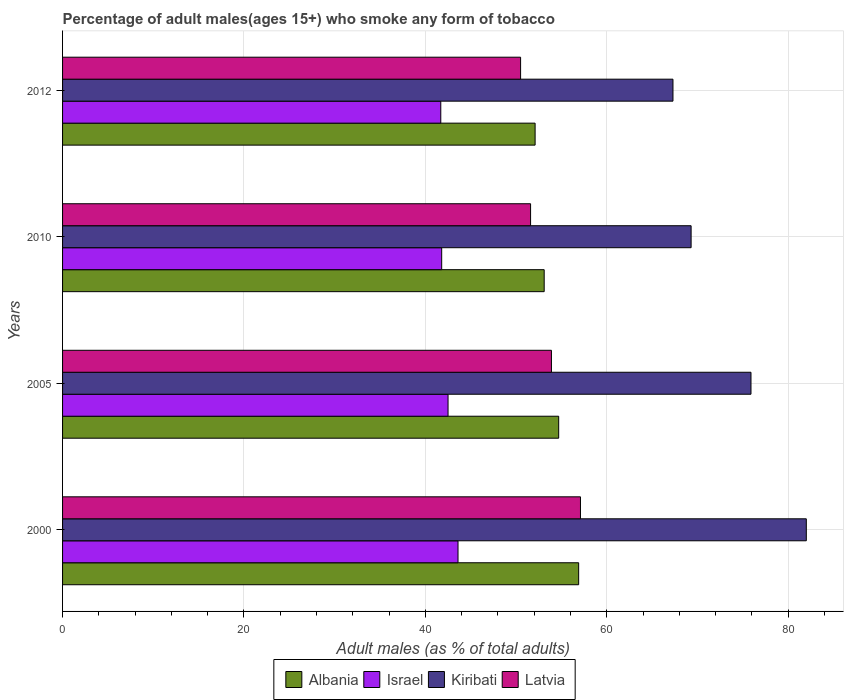How many groups of bars are there?
Your answer should be compact. 4. Are the number of bars per tick equal to the number of legend labels?
Provide a short and direct response. Yes. How many bars are there on the 4th tick from the bottom?
Your answer should be compact. 4. In how many cases, is the number of bars for a given year not equal to the number of legend labels?
Ensure brevity in your answer.  0. What is the percentage of adult males who smoke in Kiribati in 2012?
Offer a very short reply. 67.3. Across all years, what is the maximum percentage of adult males who smoke in Kiribati?
Keep it short and to the point. 82. Across all years, what is the minimum percentage of adult males who smoke in Israel?
Give a very brief answer. 41.7. In which year was the percentage of adult males who smoke in Latvia maximum?
Offer a very short reply. 2000. In which year was the percentage of adult males who smoke in Israel minimum?
Offer a terse response. 2012. What is the total percentage of adult males who smoke in Israel in the graph?
Your response must be concise. 169.6. What is the difference between the percentage of adult males who smoke in Israel in 2005 and that in 2012?
Offer a very short reply. 0.8. What is the difference between the percentage of adult males who smoke in Latvia in 2005 and the percentage of adult males who smoke in Albania in 2012?
Your response must be concise. 1.8. What is the average percentage of adult males who smoke in Albania per year?
Ensure brevity in your answer.  54.2. In the year 2010, what is the difference between the percentage of adult males who smoke in Albania and percentage of adult males who smoke in Kiribati?
Give a very brief answer. -16.2. In how many years, is the percentage of adult males who smoke in Latvia greater than 48 %?
Your answer should be compact. 4. What is the ratio of the percentage of adult males who smoke in Albania in 2005 to that in 2012?
Provide a succinct answer. 1.05. Is the percentage of adult males who smoke in Kiribati in 2000 less than that in 2005?
Provide a succinct answer. No. What is the difference between the highest and the second highest percentage of adult males who smoke in Albania?
Provide a short and direct response. 2.2. What is the difference between the highest and the lowest percentage of adult males who smoke in Israel?
Make the answer very short. 1.9. In how many years, is the percentage of adult males who smoke in Kiribati greater than the average percentage of adult males who smoke in Kiribati taken over all years?
Ensure brevity in your answer.  2. Is the sum of the percentage of adult males who smoke in Latvia in 2000 and 2005 greater than the maximum percentage of adult males who smoke in Kiribati across all years?
Give a very brief answer. Yes. Is it the case that in every year, the sum of the percentage of adult males who smoke in Latvia and percentage of adult males who smoke in Albania is greater than the sum of percentage of adult males who smoke in Kiribati and percentage of adult males who smoke in Israel?
Your answer should be compact. No. What does the 4th bar from the top in 2012 represents?
Provide a short and direct response. Albania. What does the 1st bar from the bottom in 2000 represents?
Make the answer very short. Albania. Are all the bars in the graph horizontal?
Make the answer very short. Yes. How many years are there in the graph?
Offer a very short reply. 4. Are the values on the major ticks of X-axis written in scientific E-notation?
Give a very brief answer. No. Does the graph contain any zero values?
Offer a very short reply. No. Where does the legend appear in the graph?
Keep it short and to the point. Bottom center. How are the legend labels stacked?
Your answer should be compact. Horizontal. What is the title of the graph?
Provide a short and direct response. Percentage of adult males(ages 15+) who smoke any form of tobacco. What is the label or title of the X-axis?
Offer a very short reply. Adult males (as % of total adults). What is the Adult males (as % of total adults) of Albania in 2000?
Your answer should be very brief. 56.9. What is the Adult males (as % of total adults) of Israel in 2000?
Your answer should be compact. 43.6. What is the Adult males (as % of total adults) in Latvia in 2000?
Offer a very short reply. 57.1. What is the Adult males (as % of total adults) in Albania in 2005?
Offer a terse response. 54.7. What is the Adult males (as % of total adults) of Israel in 2005?
Give a very brief answer. 42.5. What is the Adult males (as % of total adults) in Kiribati in 2005?
Offer a very short reply. 75.9. What is the Adult males (as % of total adults) in Latvia in 2005?
Keep it short and to the point. 53.9. What is the Adult males (as % of total adults) of Albania in 2010?
Provide a short and direct response. 53.1. What is the Adult males (as % of total adults) in Israel in 2010?
Give a very brief answer. 41.8. What is the Adult males (as % of total adults) of Kiribati in 2010?
Provide a succinct answer. 69.3. What is the Adult males (as % of total adults) of Latvia in 2010?
Your answer should be very brief. 51.6. What is the Adult males (as % of total adults) of Albania in 2012?
Make the answer very short. 52.1. What is the Adult males (as % of total adults) in Israel in 2012?
Offer a terse response. 41.7. What is the Adult males (as % of total adults) in Kiribati in 2012?
Your response must be concise. 67.3. What is the Adult males (as % of total adults) of Latvia in 2012?
Keep it short and to the point. 50.5. Across all years, what is the maximum Adult males (as % of total adults) in Albania?
Ensure brevity in your answer.  56.9. Across all years, what is the maximum Adult males (as % of total adults) of Israel?
Offer a very short reply. 43.6. Across all years, what is the maximum Adult males (as % of total adults) in Latvia?
Ensure brevity in your answer.  57.1. Across all years, what is the minimum Adult males (as % of total adults) of Albania?
Your answer should be compact. 52.1. Across all years, what is the minimum Adult males (as % of total adults) of Israel?
Offer a very short reply. 41.7. Across all years, what is the minimum Adult males (as % of total adults) of Kiribati?
Provide a succinct answer. 67.3. Across all years, what is the minimum Adult males (as % of total adults) of Latvia?
Provide a short and direct response. 50.5. What is the total Adult males (as % of total adults) in Albania in the graph?
Offer a very short reply. 216.8. What is the total Adult males (as % of total adults) of Israel in the graph?
Give a very brief answer. 169.6. What is the total Adult males (as % of total adults) in Kiribati in the graph?
Offer a terse response. 294.5. What is the total Adult males (as % of total adults) in Latvia in the graph?
Your answer should be very brief. 213.1. What is the difference between the Adult males (as % of total adults) of Israel in 2000 and that in 2005?
Offer a very short reply. 1.1. What is the difference between the Adult males (as % of total adults) in Albania in 2000 and that in 2010?
Keep it short and to the point. 3.8. What is the difference between the Adult males (as % of total adults) in Israel in 2000 and that in 2010?
Keep it short and to the point. 1.8. What is the difference between the Adult males (as % of total adults) in Latvia in 2000 and that in 2010?
Provide a short and direct response. 5.5. What is the difference between the Adult males (as % of total adults) in Albania in 2000 and that in 2012?
Your response must be concise. 4.8. What is the difference between the Adult males (as % of total adults) in Kiribati in 2000 and that in 2012?
Make the answer very short. 14.7. What is the difference between the Adult males (as % of total adults) in Israel in 2005 and that in 2012?
Give a very brief answer. 0.8. What is the difference between the Adult males (as % of total adults) in Latvia in 2005 and that in 2012?
Give a very brief answer. 3.4. What is the difference between the Adult males (as % of total adults) in Kiribati in 2010 and that in 2012?
Your answer should be very brief. 2. What is the difference between the Adult males (as % of total adults) of Latvia in 2010 and that in 2012?
Your answer should be compact. 1.1. What is the difference between the Adult males (as % of total adults) in Albania in 2000 and the Adult males (as % of total adults) in Israel in 2005?
Offer a terse response. 14.4. What is the difference between the Adult males (as % of total adults) of Albania in 2000 and the Adult males (as % of total adults) of Latvia in 2005?
Offer a terse response. 3. What is the difference between the Adult males (as % of total adults) of Israel in 2000 and the Adult males (as % of total adults) of Kiribati in 2005?
Provide a succinct answer. -32.3. What is the difference between the Adult males (as % of total adults) of Kiribati in 2000 and the Adult males (as % of total adults) of Latvia in 2005?
Keep it short and to the point. 28.1. What is the difference between the Adult males (as % of total adults) of Albania in 2000 and the Adult males (as % of total adults) of Israel in 2010?
Offer a very short reply. 15.1. What is the difference between the Adult males (as % of total adults) in Albania in 2000 and the Adult males (as % of total adults) in Kiribati in 2010?
Provide a short and direct response. -12.4. What is the difference between the Adult males (as % of total adults) of Albania in 2000 and the Adult males (as % of total adults) of Latvia in 2010?
Give a very brief answer. 5.3. What is the difference between the Adult males (as % of total adults) in Israel in 2000 and the Adult males (as % of total adults) in Kiribati in 2010?
Make the answer very short. -25.7. What is the difference between the Adult males (as % of total adults) of Israel in 2000 and the Adult males (as % of total adults) of Latvia in 2010?
Your answer should be very brief. -8. What is the difference between the Adult males (as % of total adults) of Kiribati in 2000 and the Adult males (as % of total adults) of Latvia in 2010?
Offer a terse response. 30.4. What is the difference between the Adult males (as % of total adults) of Israel in 2000 and the Adult males (as % of total adults) of Kiribati in 2012?
Provide a short and direct response. -23.7. What is the difference between the Adult males (as % of total adults) in Israel in 2000 and the Adult males (as % of total adults) in Latvia in 2012?
Your answer should be very brief. -6.9. What is the difference between the Adult males (as % of total adults) in Kiribati in 2000 and the Adult males (as % of total adults) in Latvia in 2012?
Provide a short and direct response. 31.5. What is the difference between the Adult males (as % of total adults) of Albania in 2005 and the Adult males (as % of total adults) of Israel in 2010?
Offer a terse response. 12.9. What is the difference between the Adult males (as % of total adults) of Albania in 2005 and the Adult males (as % of total adults) of Kiribati in 2010?
Your answer should be compact. -14.6. What is the difference between the Adult males (as % of total adults) of Israel in 2005 and the Adult males (as % of total adults) of Kiribati in 2010?
Your answer should be very brief. -26.8. What is the difference between the Adult males (as % of total adults) in Kiribati in 2005 and the Adult males (as % of total adults) in Latvia in 2010?
Give a very brief answer. 24.3. What is the difference between the Adult males (as % of total adults) of Albania in 2005 and the Adult males (as % of total adults) of Kiribati in 2012?
Your answer should be compact. -12.6. What is the difference between the Adult males (as % of total adults) of Israel in 2005 and the Adult males (as % of total adults) of Kiribati in 2012?
Keep it short and to the point. -24.8. What is the difference between the Adult males (as % of total adults) in Israel in 2005 and the Adult males (as % of total adults) in Latvia in 2012?
Provide a short and direct response. -8. What is the difference between the Adult males (as % of total adults) in Kiribati in 2005 and the Adult males (as % of total adults) in Latvia in 2012?
Provide a short and direct response. 25.4. What is the difference between the Adult males (as % of total adults) of Israel in 2010 and the Adult males (as % of total adults) of Kiribati in 2012?
Make the answer very short. -25.5. What is the difference between the Adult males (as % of total adults) in Israel in 2010 and the Adult males (as % of total adults) in Latvia in 2012?
Offer a terse response. -8.7. What is the difference between the Adult males (as % of total adults) of Kiribati in 2010 and the Adult males (as % of total adults) of Latvia in 2012?
Provide a succinct answer. 18.8. What is the average Adult males (as % of total adults) in Albania per year?
Your answer should be compact. 54.2. What is the average Adult males (as % of total adults) in Israel per year?
Your answer should be very brief. 42.4. What is the average Adult males (as % of total adults) of Kiribati per year?
Your answer should be very brief. 73.62. What is the average Adult males (as % of total adults) of Latvia per year?
Offer a very short reply. 53.27. In the year 2000, what is the difference between the Adult males (as % of total adults) in Albania and Adult males (as % of total adults) in Kiribati?
Your response must be concise. -25.1. In the year 2000, what is the difference between the Adult males (as % of total adults) of Israel and Adult males (as % of total adults) of Kiribati?
Provide a succinct answer. -38.4. In the year 2000, what is the difference between the Adult males (as % of total adults) in Israel and Adult males (as % of total adults) in Latvia?
Offer a terse response. -13.5. In the year 2000, what is the difference between the Adult males (as % of total adults) of Kiribati and Adult males (as % of total adults) of Latvia?
Offer a very short reply. 24.9. In the year 2005, what is the difference between the Adult males (as % of total adults) in Albania and Adult males (as % of total adults) in Israel?
Your response must be concise. 12.2. In the year 2005, what is the difference between the Adult males (as % of total adults) of Albania and Adult males (as % of total adults) of Kiribati?
Your response must be concise. -21.2. In the year 2005, what is the difference between the Adult males (as % of total adults) in Israel and Adult males (as % of total adults) in Kiribati?
Your answer should be very brief. -33.4. In the year 2010, what is the difference between the Adult males (as % of total adults) in Albania and Adult males (as % of total adults) in Israel?
Provide a succinct answer. 11.3. In the year 2010, what is the difference between the Adult males (as % of total adults) in Albania and Adult males (as % of total adults) in Kiribati?
Provide a succinct answer. -16.2. In the year 2010, what is the difference between the Adult males (as % of total adults) of Albania and Adult males (as % of total adults) of Latvia?
Offer a terse response. 1.5. In the year 2010, what is the difference between the Adult males (as % of total adults) in Israel and Adult males (as % of total adults) in Kiribati?
Your answer should be compact. -27.5. In the year 2010, what is the difference between the Adult males (as % of total adults) of Kiribati and Adult males (as % of total adults) of Latvia?
Your answer should be very brief. 17.7. In the year 2012, what is the difference between the Adult males (as % of total adults) in Albania and Adult males (as % of total adults) in Israel?
Your answer should be very brief. 10.4. In the year 2012, what is the difference between the Adult males (as % of total adults) in Albania and Adult males (as % of total adults) in Kiribati?
Give a very brief answer. -15.2. In the year 2012, what is the difference between the Adult males (as % of total adults) in Albania and Adult males (as % of total adults) in Latvia?
Offer a very short reply. 1.6. In the year 2012, what is the difference between the Adult males (as % of total adults) of Israel and Adult males (as % of total adults) of Kiribati?
Keep it short and to the point. -25.6. In the year 2012, what is the difference between the Adult males (as % of total adults) in Israel and Adult males (as % of total adults) in Latvia?
Your response must be concise. -8.8. In the year 2012, what is the difference between the Adult males (as % of total adults) of Kiribati and Adult males (as % of total adults) of Latvia?
Ensure brevity in your answer.  16.8. What is the ratio of the Adult males (as % of total adults) of Albania in 2000 to that in 2005?
Provide a succinct answer. 1.04. What is the ratio of the Adult males (as % of total adults) of Israel in 2000 to that in 2005?
Offer a terse response. 1.03. What is the ratio of the Adult males (as % of total adults) of Kiribati in 2000 to that in 2005?
Give a very brief answer. 1.08. What is the ratio of the Adult males (as % of total adults) of Latvia in 2000 to that in 2005?
Keep it short and to the point. 1.06. What is the ratio of the Adult males (as % of total adults) in Albania in 2000 to that in 2010?
Offer a very short reply. 1.07. What is the ratio of the Adult males (as % of total adults) in Israel in 2000 to that in 2010?
Give a very brief answer. 1.04. What is the ratio of the Adult males (as % of total adults) of Kiribati in 2000 to that in 2010?
Give a very brief answer. 1.18. What is the ratio of the Adult males (as % of total adults) of Latvia in 2000 to that in 2010?
Your response must be concise. 1.11. What is the ratio of the Adult males (as % of total adults) in Albania in 2000 to that in 2012?
Your response must be concise. 1.09. What is the ratio of the Adult males (as % of total adults) in Israel in 2000 to that in 2012?
Offer a terse response. 1.05. What is the ratio of the Adult males (as % of total adults) in Kiribati in 2000 to that in 2012?
Keep it short and to the point. 1.22. What is the ratio of the Adult males (as % of total adults) of Latvia in 2000 to that in 2012?
Ensure brevity in your answer.  1.13. What is the ratio of the Adult males (as % of total adults) of Albania in 2005 to that in 2010?
Ensure brevity in your answer.  1.03. What is the ratio of the Adult males (as % of total adults) in Israel in 2005 to that in 2010?
Provide a succinct answer. 1.02. What is the ratio of the Adult males (as % of total adults) in Kiribati in 2005 to that in 2010?
Your answer should be compact. 1.1. What is the ratio of the Adult males (as % of total adults) of Latvia in 2005 to that in 2010?
Keep it short and to the point. 1.04. What is the ratio of the Adult males (as % of total adults) of Albania in 2005 to that in 2012?
Ensure brevity in your answer.  1.05. What is the ratio of the Adult males (as % of total adults) of Israel in 2005 to that in 2012?
Make the answer very short. 1.02. What is the ratio of the Adult males (as % of total adults) in Kiribati in 2005 to that in 2012?
Make the answer very short. 1.13. What is the ratio of the Adult males (as % of total adults) of Latvia in 2005 to that in 2012?
Provide a short and direct response. 1.07. What is the ratio of the Adult males (as % of total adults) in Albania in 2010 to that in 2012?
Make the answer very short. 1.02. What is the ratio of the Adult males (as % of total adults) of Israel in 2010 to that in 2012?
Your answer should be very brief. 1. What is the ratio of the Adult males (as % of total adults) in Kiribati in 2010 to that in 2012?
Your answer should be compact. 1.03. What is the ratio of the Adult males (as % of total adults) of Latvia in 2010 to that in 2012?
Make the answer very short. 1.02. What is the difference between the highest and the second highest Adult males (as % of total adults) in Israel?
Your response must be concise. 1.1. What is the difference between the highest and the lowest Adult males (as % of total adults) in Albania?
Make the answer very short. 4.8. What is the difference between the highest and the lowest Adult males (as % of total adults) in Israel?
Your response must be concise. 1.9. What is the difference between the highest and the lowest Adult males (as % of total adults) of Latvia?
Your response must be concise. 6.6. 